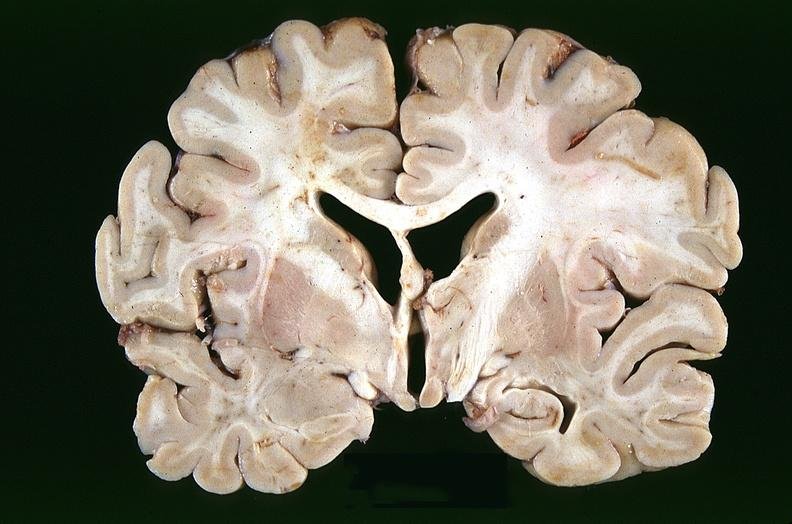s lymphoid atrophy in newborn present?
Answer the question using a single word or phrase. No 